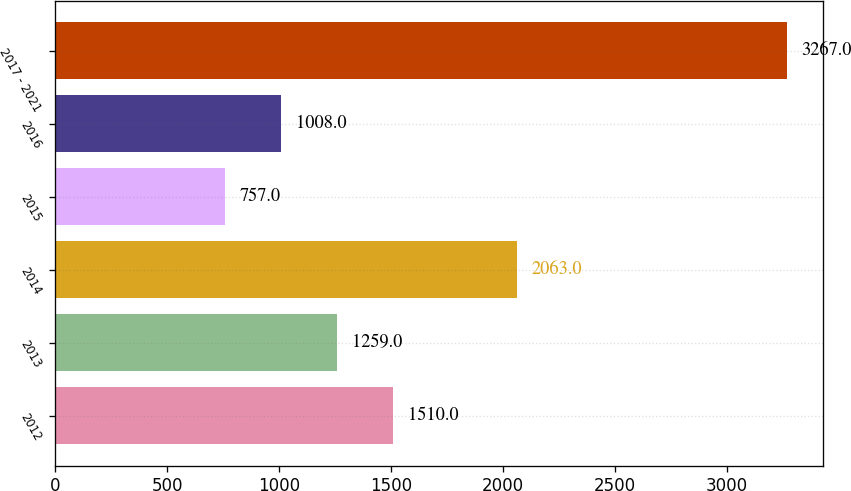Convert chart to OTSL. <chart><loc_0><loc_0><loc_500><loc_500><bar_chart><fcel>2012<fcel>2013<fcel>2014<fcel>2015<fcel>2016<fcel>2017 - 2021<nl><fcel>1510<fcel>1259<fcel>2063<fcel>757<fcel>1008<fcel>3267<nl></chart> 